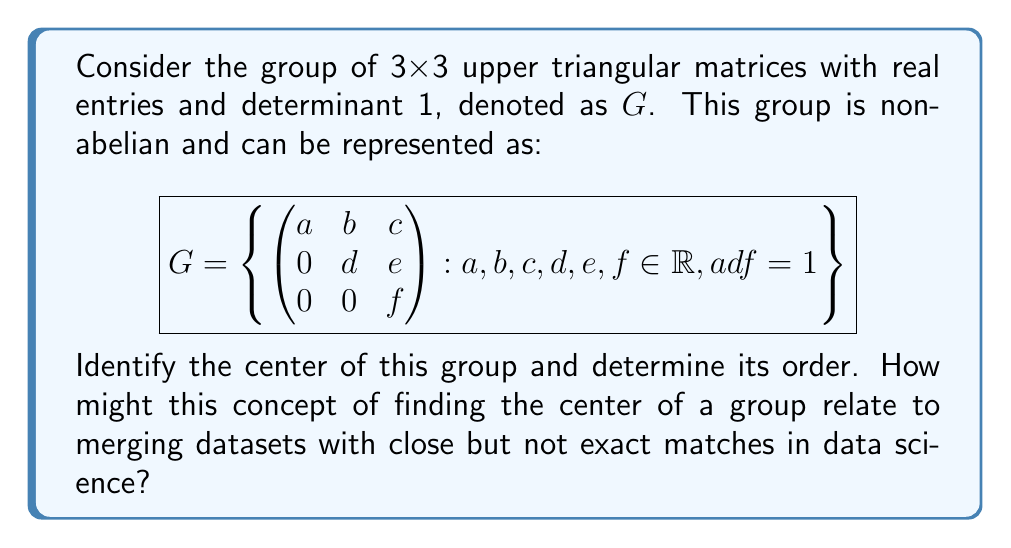What is the answer to this math problem? To solve this problem, we'll follow these steps:

1) First, recall that the center of a group $G$ is defined as:
   $$Z(G) = \{z \in G : zg = gz \text{ for all } g \in G\}$$

2) For a matrix $Z = \begin{pmatrix} a & b & c \\ 0 & d & e \\ 0 & 0 & f \end{pmatrix}$ to be in the center, it must commute with all matrices in $G$.

3) Let's consider a general element $G = \begin{pmatrix} x & y & z \\ 0 & w & v \\ 0 & 0 & u \end{pmatrix}$ in $G$. For $Z$ to be in the center, we must have $ZG = GZ$ for all such $G$.

4) Multiplying these matrices:

   $$ZG = \begin{pmatrix} ax & ay+bw & az+bv+cu \\ 0 & dw & dv+eu \\ 0 & 0 & fu \end{pmatrix}$$

   $$GZ = \begin{pmatrix} ax & bx+ay & cx+by+az \\ 0 & dw & ew+dv \\ 0 & 0 & fu \end{pmatrix}$$

5) For these to be equal for all choices of $x, y, z, w, v, u$, we must have:
   - $b = 0$ (comparing the (1,2) entries)
   - $c = 0$ (comparing the (1,3) entries)
   - $e = 0$ (comparing the (2,3) entries)
   - $a = d = f$ (since $adf = 1$ and $a = d = f$ is the only way to make all other entries match)

6) Therefore, the center consists of matrices of the form:

   $$Z(G) = \left\{ \begin{pmatrix} a & 0 & 0 \\ 0 & a & 0 \\ 0 & 0 & a \end{pmatrix} : a \in \mathbb{R}, a^3 = 1 \right\}$$

7) The only real number that satisfies $a^3 = 1$ is $a = 1$. Thus, the center consists of only the identity matrix.

8) Therefore, the order of the center is 1.

Relating to data science and the `merge_asof` method:
The concept of finding the center of a group involves identifying elements that "play well" (commute) with all other elements. Similarly, in data merging, the `merge_asof` method in pandas tries to find the closest match when an exact match is not available. Both concepts involve finding elements (or data points) that best align or "commute" with others, even if not perfectly.
Answer: The center of the group $G$ is $Z(G) = \{\mathbf{I}\}$, where $\mathbf{I}$ is the 3x3 identity matrix. The order of the center is 1. 